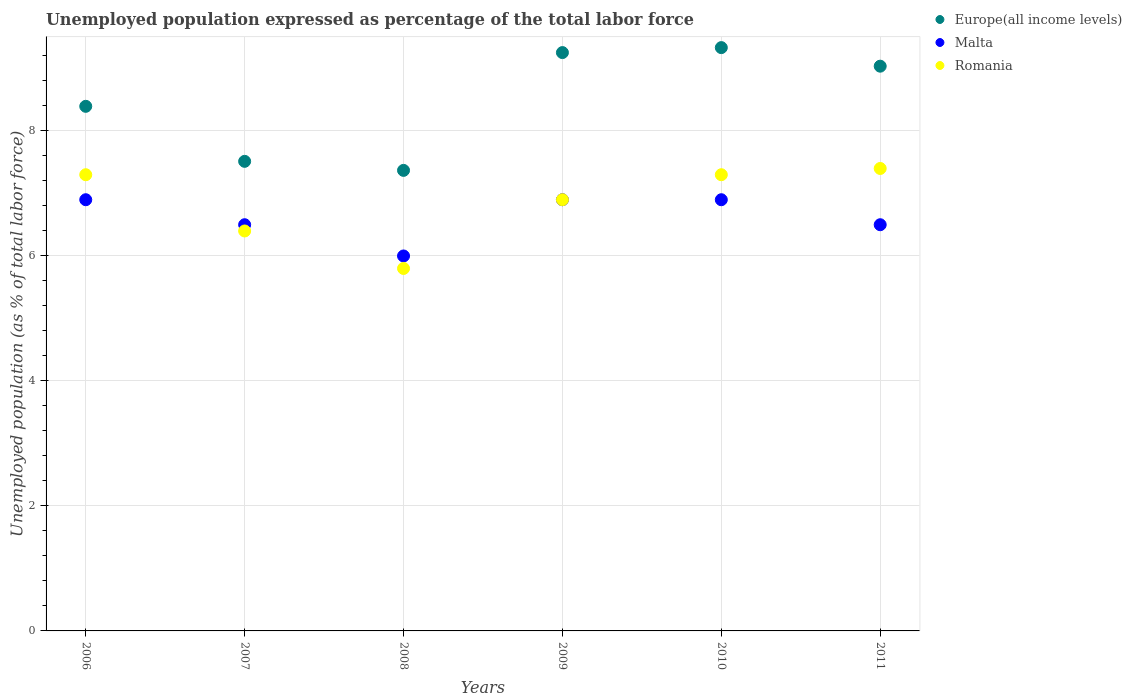Is the number of dotlines equal to the number of legend labels?
Give a very brief answer. Yes. Across all years, what is the maximum unemployment in in Romania?
Your response must be concise. 7.4. What is the total unemployment in in Europe(all income levels) in the graph?
Offer a very short reply. 50.9. What is the difference between the unemployment in in Malta in 2006 and that in 2007?
Provide a short and direct response. 0.4. What is the difference between the unemployment in in Romania in 2010 and the unemployment in in Europe(all income levels) in 2009?
Offer a terse response. -1.95. What is the average unemployment in in Romania per year?
Offer a very short reply. 6.85. In the year 2010, what is the difference between the unemployment in in Malta and unemployment in in Europe(all income levels)?
Give a very brief answer. -2.43. In how many years, is the unemployment in in Europe(all income levels) greater than 0.4 %?
Provide a short and direct response. 6. What is the ratio of the unemployment in in Romania in 2007 to that in 2010?
Provide a succinct answer. 0.88. Is the unemployment in in Malta in 2006 less than that in 2007?
Provide a short and direct response. No. What is the difference between the highest and the second highest unemployment in in Romania?
Offer a very short reply. 0.1. What is the difference between the highest and the lowest unemployment in in Romania?
Offer a terse response. 1.6. In how many years, is the unemployment in in Malta greater than the average unemployment in in Malta taken over all years?
Ensure brevity in your answer.  3. Does the unemployment in in Romania monotonically increase over the years?
Offer a terse response. No. Is the unemployment in in Europe(all income levels) strictly greater than the unemployment in in Romania over the years?
Your response must be concise. Yes. Is the unemployment in in Europe(all income levels) strictly less than the unemployment in in Romania over the years?
Make the answer very short. No. How many dotlines are there?
Offer a very short reply. 3. Does the graph contain any zero values?
Your response must be concise. No. Where does the legend appear in the graph?
Provide a succinct answer. Top right. What is the title of the graph?
Give a very brief answer. Unemployed population expressed as percentage of the total labor force. Does "Middle East & North Africa (all income levels)" appear as one of the legend labels in the graph?
Ensure brevity in your answer.  No. What is the label or title of the Y-axis?
Your response must be concise. Unemployed population (as % of total labor force). What is the Unemployed population (as % of total labor force) of Europe(all income levels) in 2006?
Make the answer very short. 8.39. What is the Unemployed population (as % of total labor force) in Malta in 2006?
Provide a succinct answer. 6.9. What is the Unemployed population (as % of total labor force) of Romania in 2006?
Offer a very short reply. 7.3. What is the Unemployed population (as % of total labor force) of Europe(all income levels) in 2007?
Give a very brief answer. 7.51. What is the Unemployed population (as % of total labor force) in Malta in 2007?
Provide a succinct answer. 6.5. What is the Unemployed population (as % of total labor force) of Romania in 2007?
Keep it short and to the point. 6.4. What is the Unemployed population (as % of total labor force) in Europe(all income levels) in 2008?
Your answer should be very brief. 7.37. What is the Unemployed population (as % of total labor force) in Malta in 2008?
Keep it short and to the point. 6. What is the Unemployed population (as % of total labor force) in Romania in 2008?
Give a very brief answer. 5.8. What is the Unemployed population (as % of total labor force) of Europe(all income levels) in 2009?
Keep it short and to the point. 9.25. What is the Unemployed population (as % of total labor force) in Malta in 2009?
Your answer should be very brief. 6.9. What is the Unemployed population (as % of total labor force) of Romania in 2009?
Your response must be concise. 6.9. What is the Unemployed population (as % of total labor force) of Europe(all income levels) in 2010?
Your response must be concise. 9.33. What is the Unemployed population (as % of total labor force) of Malta in 2010?
Provide a succinct answer. 6.9. What is the Unemployed population (as % of total labor force) in Romania in 2010?
Give a very brief answer. 7.3. What is the Unemployed population (as % of total labor force) in Europe(all income levels) in 2011?
Offer a terse response. 9.04. What is the Unemployed population (as % of total labor force) in Romania in 2011?
Your answer should be very brief. 7.4. Across all years, what is the maximum Unemployed population (as % of total labor force) in Europe(all income levels)?
Make the answer very short. 9.33. Across all years, what is the maximum Unemployed population (as % of total labor force) in Malta?
Your answer should be very brief. 6.9. Across all years, what is the maximum Unemployed population (as % of total labor force) in Romania?
Your answer should be very brief. 7.4. Across all years, what is the minimum Unemployed population (as % of total labor force) of Europe(all income levels)?
Your answer should be very brief. 7.37. Across all years, what is the minimum Unemployed population (as % of total labor force) of Malta?
Your answer should be very brief. 6. Across all years, what is the minimum Unemployed population (as % of total labor force) in Romania?
Keep it short and to the point. 5.8. What is the total Unemployed population (as % of total labor force) of Europe(all income levels) in the graph?
Offer a very short reply. 50.9. What is the total Unemployed population (as % of total labor force) of Malta in the graph?
Ensure brevity in your answer.  39.7. What is the total Unemployed population (as % of total labor force) in Romania in the graph?
Offer a terse response. 41.1. What is the difference between the Unemployed population (as % of total labor force) in Europe(all income levels) in 2006 and that in 2007?
Ensure brevity in your answer.  0.88. What is the difference between the Unemployed population (as % of total labor force) of Malta in 2006 and that in 2007?
Give a very brief answer. 0.4. What is the difference between the Unemployed population (as % of total labor force) of Europe(all income levels) in 2006 and that in 2008?
Keep it short and to the point. 1.03. What is the difference between the Unemployed population (as % of total labor force) in Malta in 2006 and that in 2008?
Offer a very short reply. 0.9. What is the difference between the Unemployed population (as % of total labor force) of Europe(all income levels) in 2006 and that in 2009?
Make the answer very short. -0.86. What is the difference between the Unemployed population (as % of total labor force) in Malta in 2006 and that in 2009?
Provide a succinct answer. 0. What is the difference between the Unemployed population (as % of total labor force) of Romania in 2006 and that in 2009?
Your answer should be very brief. 0.4. What is the difference between the Unemployed population (as % of total labor force) in Europe(all income levels) in 2006 and that in 2010?
Provide a succinct answer. -0.94. What is the difference between the Unemployed population (as % of total labor force) of Malta in 2006 and that in 2010?
Your response must be concise. 0. What is the difference between the Unemployed population (as % of total labor force) in Europe(all income levels) in 2006 and that in 2011?
Your answer should be very brief. -0.64. What is the difference between the Unemployed population (as % of total labor force) of Romania in 2006 and that in 2011?
Provide a short and direct response. -0.1. What is the difference between the Unemployed population (as % of total labor force) of Europe(all income levels) in 2007 and that in 2008?
Provide a short and direct response. 0.14. What is the difference between the Unemployed population (as % of total labor force) of Europe(all income levels) in 2007 and that in 2009?
Provide a short and direct response. -1.74. What is the difference between the Unemployed population (as % of total labor force) of Malta in 2007 and that in 2009?
Give a very brief answer. -0.4. What is the difference between the Unemployed population (as % of total labor force) in Europe(all income levels) in 2007 and that in 2010?
Make the answer very short. -1.82. What is the difference between the Unemployed population (as % of total labor force) in Malta in 2007 and that in 2010?
Ensure brevity in your answer.  -0.4. What is the difference between the Unemployed population (as % of total labor force) of Europe(all income levels) in 2007 and that in 2011?
Offer a terse response. -1.52. What is the difference between the Unemployed population (as % of total labor force) of Malta in 2007 and that in 2011?
Offer a terse response. 0. What is the difference between the Unemployed population (as % of total labor force) in Europe(all income levels) in 2008 and that in 2009?
Your response must be concise. -1.88. What is the difference between the Unemployed population (as % of total labor force) in Romania in 2008 and that in 2009?
Keep it short and to the point. -1.1. What is the difference between the Unemployed population (as % of total labor force) of Europe(all income levels) in 2008 and that in 2010?
Make the answer very short. -1.96. What is the difference between the Unemployed population (as % of total labor force) in Europe(all income levels) in 2008 and that in 2011?
Ensure brevity in your answer.  -1.67. What is the difference between the Unemployed population (as % of total labor force) of Romania in 2008 and that in 2011?
Your answer should be very brief. -1.6. What is the difference between the Unemployed population (as % of total labor force) of Europe(all income levels) in 2009 and that in 2010?
Provide a short and direct response. -0.08. What is the difference between the Unemployed population (as % of total labor force) of Europe(all income levels) in 2009 and that in 2011?
Offer a very short reply. 0.22. What is the difference between the Unemployed population (as % of total labor force) of Malta in 2009 and that in 2011?
Keep it short and to the point. 0.4. What is the difference between the Unemployed population (as % of total labor force) in Europe(all income levels) in 2010 and that in 2011?
Keep it short and to the point. 0.3. What is the difference between the Unemployed population (as % of total labor force) in Europe(all income levels) in 2006 and the Unemployed population (as % of total labor force) in Malta in 2007?
Provide a short and direct response. 1.89. What is the difference between the Unemployed population (as % of total labor force) of Europe(all income levels) in 2006 and the Unemployed population (as % of total labor force) of Romania in 2007?
Your response must be concise. 1.99. What is the difference between the Unemployed population (as % of total labor force) in Europe(all income levels) in 2006 and the Unemployed population (as % of total labor force) in Malta in 2008?
Provide a short and direct response. 2.39. What is the difference between the Unemployed population (as % of total labor force) of Europe(all income levels) in 2006 and the Unemployed population (as % of total labor force) of Romania in 2008?
Keep it short and to the point. 2.59. What is the difference between the Unemployed population (as % of total labor force) of Europe(all income levels) in 2006 and the Unemployed population (as % of total labor force) of Malta in 2009?
Make the answer very short. 1.49. What is the difference between the Unemployed population (as % of total labor force) of Europe(all income levels) in 2006 and the Unemployed population (as % of total labor force) of Romania in 2009?
Provide a succinct answer. 1.49. What is the difference between the Unemployed population (as % of total labor force) in Europe(all income levels) in 2006 and the Unemployed population (as % of total labor force) in Malta in 2010?
Your answer should be compact. 1.49. What is the difference between the Unemployed population (as % of total labor force) in Europe(all income levels) in 2006 and the Unemployed population (as % of total labor force) in Romania in 2010?
Keep it short and to the point. 1.09. What is the difference between the Unemployed population (as % of total labor force) in Europe(all income levels) in 2006 and the Unemployed population (as % of total labor force) in Malta in 2011?
Your answer should be very brief. 1.89. What is the difference between the Unemployed population (as % of total labor force) in Europe(all income levels) in 2007 and the Unemployed population (as % of total labor force) in Malta in 2008?
Keep it short and to the point. 1.51. What is the difference between the Unemployed population (as % of total labor force) of Europe(all income levels) in 2007 and the Unemployed population (as % of total labor force) of Romania in 2008?
Provide a succinct answer. 1.71. What is the difference between the Unemployed population (as % of total labor force) in Europe(all income levels) in 2007 and the Unemployed population (as % of total labor force) in Malta in 2009?
Provide a short and direct response. 0.61. What is the difference between the Unemployed population (as % of total labor force) in Europe(all income levels) in 2007 and the Unemployed population (as % of total labor force) in Romania in 2009?
Give a very brief answer. 0.61. What is the difference between the Unemployed population (as % of total labor force) of Europe(all income levels) in 2007 and the Unemployed population (as % of total labor force) of Malta in 2010?
Your answer should be compact. 0.61. What is the difference between the Unemployed population (as % of total labor force) of Europe(all income levels) in 2007 and the Unemployed population (as % of total labor force) of Romania in 2010?
Your response must be concise. 0.21. What is the difference between the Unemployed population (as % of total labor force) in Europe(all income levels) in 2007 and the Unemployed population (as % of total labor force) in Malta in 2011?
Offer a terse response. 1.01. What is the difference between the Unemployed population (as % of total labor force) of Europe(all income levels) in 2007 and the Unemployed population (as % of total labor force) of Romania in 2011?
Offer a terse response. 0.11. What is the difference between the Unemployed population (as % of total labor force) of Malta in 2007 and the Unemployed population (as % of total labor force) of Romania in 2011?
Your answer should be compact. -0.9. What is the difference between the Unemployed population (as % of total labor force) in Europe(all income levels) in 2008 and the Unemployed population (as % of total labor force) in Malta in 2009?
Give a very brief answer. 0.47. What is the difference between the Unemployed population (as % of total labor force) in Europe(all income levels) in 2008 and the Unemployed population (as % of total labor force) in Romania in 2009?
Provide a short and direct response. 0.47. What is the difference between the Unemployed population (as % of total labor force) in Malta in 2008 and the Unemployed population (as % of total labor force) in Romania in 2009?
Your answer should be compact. -0.9. What is the difference between the Unemployed population (as % of total labor force) in Europe(all income levels) in 2008 and the Unemployed population (as % of total labor force) in Malta in 2010?
Your response must be concise. 0.47. What is the difference between the Unemployed population (as % of total labor force) of Europe(all income levels) in 2008 and the Unemployed population (as % of total labor force) of Romania in 2010?
Provide a succinct answer. 0.07. What is the difference between the Unemployed population (as % of total labor force) in Europe(all income levels) in 2008 and the Unemployed population (as % of total labor force) in Malta in 2011?
Offer a terse response. 0.87. What is the difference between the Unemployed population (as % of total labor force) in Europe(all income levels) in 2008 and the Unemployed population (as % of total labor force) in Romania in 2011?
Offer a terse response. -0.03. What is the difference between the Unemployed population (as % of total labor force) in Malta in 2008 and the Unemployed population (as % of total labor force) in Romania in 2011?
Keep it short and to the point. -1.4. What is the difference between the Unemployed population (as % of total labor force) in Europe(all income levels) in 2009 and the Unemployed population (as % of total labor force) in Malta in 2010?
Make the answer very short. 2.35. What is the difference between the Unemployed population (as % of total labor force) in Europe(all income levels) in 2009 and the Unemployed population (as % of total labor force) in Romania in 2010?
Offer a very short reply. 1.95. What is the difference between the Unemployed population (as % of total labor force) in Europe(all income levels) in 2009 and the Unemployed population (as % of total labor force) in Malta in 2011?
Keep it short and to the point. 2.75. What is the difference between the Unemployed population (as % of total labor force) in Europe(all income levels) in 2009 and the Unemployed population (as % of total labor force) in Romania in 2011?
Give a very brief answer. 1.85. What is the difference between the Unemployed population (as % of total labor force) of Malta in 2009 and the Unemployed population (as % of total labor force) of Romania in 2011?
Provide a short and direct response. -0.5. What is the difference between the Unemployed population (as % of total labor force) in Europe(all income levels) in 2010 and the Unemployed population (as % of total labor force) in Malta in 2011?
Your answer should be very brief. 2.83. What is the difference between the Unemployed population (as % of total labor force) in Europe(all income levels) in 2010 and the Unemployed population (as % of total labor force) in Romania in 2011?
Offer a terse response. 1.93. What is the difference between the Unemployed population (as % of total labor force) of Malta in 2010 and the Unemployed population (as % of total labor force) of Romania in 2011?
Your answer should be very brief. -0.5. What is the average Unemployed population (as % of total labor force) of Europe(all income levels) per year?
Offer a very short reply. 8.48. What is the average Unemployed population (as % of total labor force) in Malta per year?
Offer a very short reply. 6.62. What is the average Unemployed population (as % of total labor force) in Romania per year?
Offer a terse response. 6.85. In the year 2006, what is the difference between the Unemployed population (as % of total labor force) of Europe(all income levels) and Unemployed population (as % of total labor force) of Malta?
Ensure brevity in your answer.  1.49. In the year 2006, what is the difference between the Unemployed population (as % of total labor force) in Europe(all income levels) and Unemployed population (as % of total labor force) in Romania?
Keep it short and to the point. 1.09. In the year 2006, what is the difference between the Unemployed population (as % of total labor force) of Malta and Unemployed population (as % of total labor force) of Romania?
Ensure brevity in your answer.  -0.4. In the year 2007, what is the difference between the Unemployed population (as % of total labor force) in Europe(all income levels) and Unemployed population (as % of total labor force) in Malta?
Keep it short and to the point. 1.01. In the year 2007, what is the difference between the Unemployed population (as % of total labor force) of Europe(all income levels) and Unemployed population (as % of total labor force) of Romania?
Make the answer very short. 1.11. In the year 2007, what is the difference between the Unemployed population (as % of total labor force) of Malta and Unemployed population (as % of total labor force) of Romania?
Provide a succinct answer. 0.1. In the year 2008, what is the difference between the Unemployed population (as % of total labor force) in Europe(all income levels) and Unemployed population (as % of total labor force) in Malta?
Provide a succinct answer. 1.37. In the year 2008, what is the difference between the Unemployed population (as % of total labor force) in Europe(all income levels) and Unemployed population (as % of total labor force) in Romania?
Provide a short and direct response. 1.57. In the year 2008, what is the difference between the Unemployed population (as % of total labor force) in Malta and Unemployed population (as % of total labor force) in Romania?
Ensure brevity in your answer.  0.2. In the year 2009, what is the difference between the Unemployed population (as % of total labor force) of Europe(all income levels) and Unemployed population (as % of total labor force) of Malta?
Your response must be concise. 2.35. In the year 2009, what is the difference between the Unemployed population (as % of total labor force) of Europe(all income levels) and Unemployed population (as % of total labor force) of Romania?
Your response must be concise. 2.35. In the year 2010, what is the difference between the Unemployed population (as % of total labor force) in Europe(all income levels) and Unemployed population (as % of total labor force) in Malta?
Your answer should be very brief. 2.43. In the year 2010, what is the difference between the Unemployed population (as % of total labor force) of Europe(all income levels) and Unemployed population (as % of total labor force) of Romania?
Keep it short and to the point. 2.03. In the year 2011, what is the difference between the Unemployed population (as % of total labor force) of Europe(all income levels) and Unemployed population (as % of total labor force) of Malta?
Provide a short and direct response. 2.54. In the year 2011, what is the difference between the Unemployed population (as % of total labor force) in Europe(all income levels) and Unemployed population (as % of total labor force) in Romania?
Offer a very short reply. 1.64. What is the ratio of the Unemployed population (as % of total labor force) in Europe(all income levels) in 2006 to that in 2007?
Ensure brevity in your answer.  1.12. What is the ratio of the Unemployed population (as % of total labor force) of Malta in 2006 to that in 2007?
Offer a terse response. 1.06. What is the ratio of the Unemployed population (as % of total labor force) of Romania in 2006 to that in 2007?
Provide a succinct answer. 1.14. What is the ratio of the Unemployed population (as % of total labor force) of Europe(all income levels) in 2006 to that in 2008?
Provide a short and direct response. 1.14. What is the ratio of the Unemployed population (as % of total labor force) of Malta in 2006 to that in 2008?
Provide a succinct answer. 1.15. What is the ratio of the Unemployed population (as % of total labor force) in Romania in 2006 to that in 2008?
Your answer should be very brief. 1.26. What is the ratio of the Unemployed population (as % of total labor force) in Europe(all income levels) in 2006 to that in 2009?
Provide a short and direct response. 0.91. What is the ratio of the Unemployed population (as % of total labor force) in Malta in 2006 to that in 2009?
Offer a very short reply. 1. What is the ratio of the Unemployed population (as % of total labor force) in Romania in 2006 to that in 2009?
Provide a short and direct response. 1.06. What is the ratio of the Unemployed population (as % of total labor force) of Europe(all income levels) in 2006 to that in 2010?
Provide a short and direct response. 0.9. What is the ratio of the Unemployed population (as % of total labor force) in Malta in 2006 to that in 2010?
Give a very brief answer. 1. What is the ratio of the Unemployed population (as % of total labor force) of Europe(all income levels) in 2006 to that in 2011?
Make the answer very short. 0.93. What is the ratio of the Unemployed population (as % of total labor force) of Malta in 2006 to that in 2011?
Your answer should be compact. 1.06. What is the ratio of the Unemployed population (as % of total labor force) of Romania in 2006 to that in 2011?
Keep it short and to the point. 0.99. What is the ratio of the Unemployed population (as % of total labor force) of Europe(all income levels) in 2007 to that in 2008?
Offer a terse response. 1.02. What is the ratio of the Unemployed population (as % of total labor force) of Romania in 2007 to that in 2008?
Provide a succinct answer. 1.1. What is the ratio of the Unemployed population (as % of total labor force) in Europe(all income levels) in 2007 to that in 2009?
Your answer should be very brief. 0.81. What is the ratio of the Unemployed population (as % of total labor force) in Malta in 2007 to that in 2009?
Keep it short and to the point. 0.94. What is the ratio of the Unemployed population (as % of total labor force) in Romania in 2007 to that in 2009?
Your response must be concise. 0.93. What is the ratio of the Unemployed population (as % of total labor force) in Europe(all income levels) in 2007 to that in 2010?
Make the answer very short. 0.81. What is the ratio of the Unemployed population (as % of total labor force) in Malta in 2007 to that in 2010?
Provide a succinct answer. 0.94. What is the ratio of the Unemployed population (as % of total labor force) in Romania in 2007 to that in 2010?
Your answer should be very brief. 0.88. What is the ratio of the Unemployed population (as % of total labor force) in Europe(all income levels) in 2007 to that in 2011?
Your answer should be very brief. 0.83. What is the ratio of the Unemployed population (as % of total labor force) in Malta in 2007 to that in 2011?
Give a very brief answer. 1. What is the ratio of the Unemployed population (as % of total labor force) of Romania in 2007 to that in 2011?
Your answer should be very brief. 0.86. What is the ratio of the Unemployed population (as % of total labor force) of Europe(all income levels) in 2008 to that in 2009?
Offer a very short reply. 0.8. What is the ratio of the Unemployed population (as % of total labor force) of Malta in 2008 to that in 2009?
Offer a terse response. 0.87. What is the ratio of the Unemployed population (as % of total labor force) of Romania in 2008 to that in 2009?
Give a very brief answer. 0.84. What is the ratio of the Unemployed population (as % of total labor force) in Europe(all income levels) in 2008 to that in 2010?
Provide a short and direct response. 0.79. What is the ratio of the Unemployed population (as % of total labor force) of Malta in 2008 to that in 2010?
Provide a succinct answer. 0.87. What is the ratio of the Unemployed population (as % of total labor force) in Romania in 2008 to that in 2010?
Your answer should be compact. 0.79. What is the ratio of the Unemployed population (as % of total labor force) of Europe(all income levels) in 2008 to that in 2011?
Provide a succinct answer. 0.82. What is the ratio of the Unemployed population (as % of total labor force) in Malta in 2008 to that in 2011?
Keep it short and to the point. 0.92. What is the ratio of the Unemployed population (as % of total labor force) of Romania in 2008 to that in 2011?
Ensure brevity in your answer.  0.78. What is the ratio of the Unemployed population (as % of total labor force) in Europe(all income levels) in 2009 to that in 2010?
Provide a short and direct response. 0.99. What is the ratio of the Unemployed population (as % of total labor force) of Malta in 2009 to that in 2010?
Your answer should be very brief. 1. What is the ratio of the Unemployed population (as % of total labor force) in Romania in 2009 to that in 2010?
Ensure brevity in your answer.  0.95. What is the ratio of the Unemployed population (as % of total labor force) of Europe(all income levels) in 2009 to that in 2011?
Your response must be concise. 1.02. What is the ratio of the Unemployed population (as % of total labor force) in Malta in 2009 to that in 2011?
Give a very brief answer. 1.06. What is the ratio of the Unemployed population (as % of total labor force) in Romania in 2009 to that in 2011?
Provide a succinct answer. 0.93. What is the ratio of the Unemployed population (as % of total labor force) in Europe(all income levels) in 2010 to that in 2011?
Offer a terse response. 1.03. What is the ratio of the Unemployed population (as % of total labor force) of Malta in 2010 to that in 2011?
Your response must be concise. 1.06. What is the ratio of the Unemployed population (as % of total labor force) of Romania in 2010 to that in 2011?
Make the answer very short. 0.99. What is the difference between the highest and the second highest Unemployed population (as % of total labor force) in Europe(all income levels)?
Make the answer very short. 0.08. What is the difference between the highest and the second highest Unemployed population (as % of total labor force) of Malta?
Your answer should be very brief. 0. What is the difference between the highest and the lowest Unemployed population (as % of total labor force) in Europe(all income levels)?
Provide a short and direct response. 1.96. 